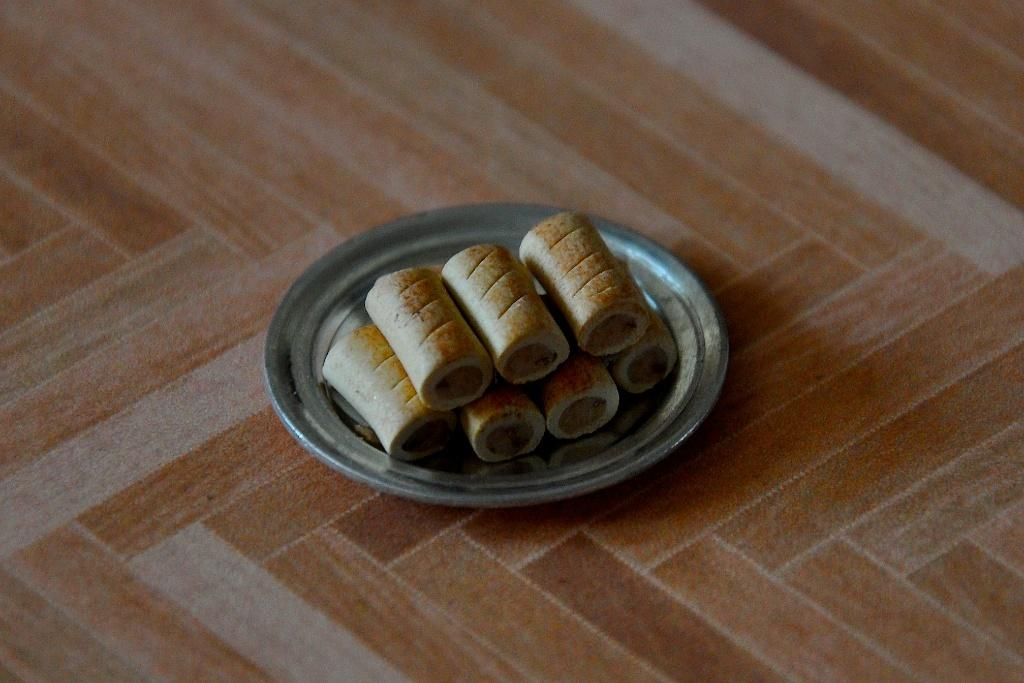What object is present in the image that is typically used for serving food? There is a plate in the image. What is on the plate in the image? There are food items on the plate. Where is the plate located in the image? The plate is placed on a platform. What type of cake is being served on the plate in the image? There is no cake present on the plate in the image. How does the memory of the food items on the plate affect the society in the image? There is no reference to memory or society in the image; it only features a plate with food items on it. 